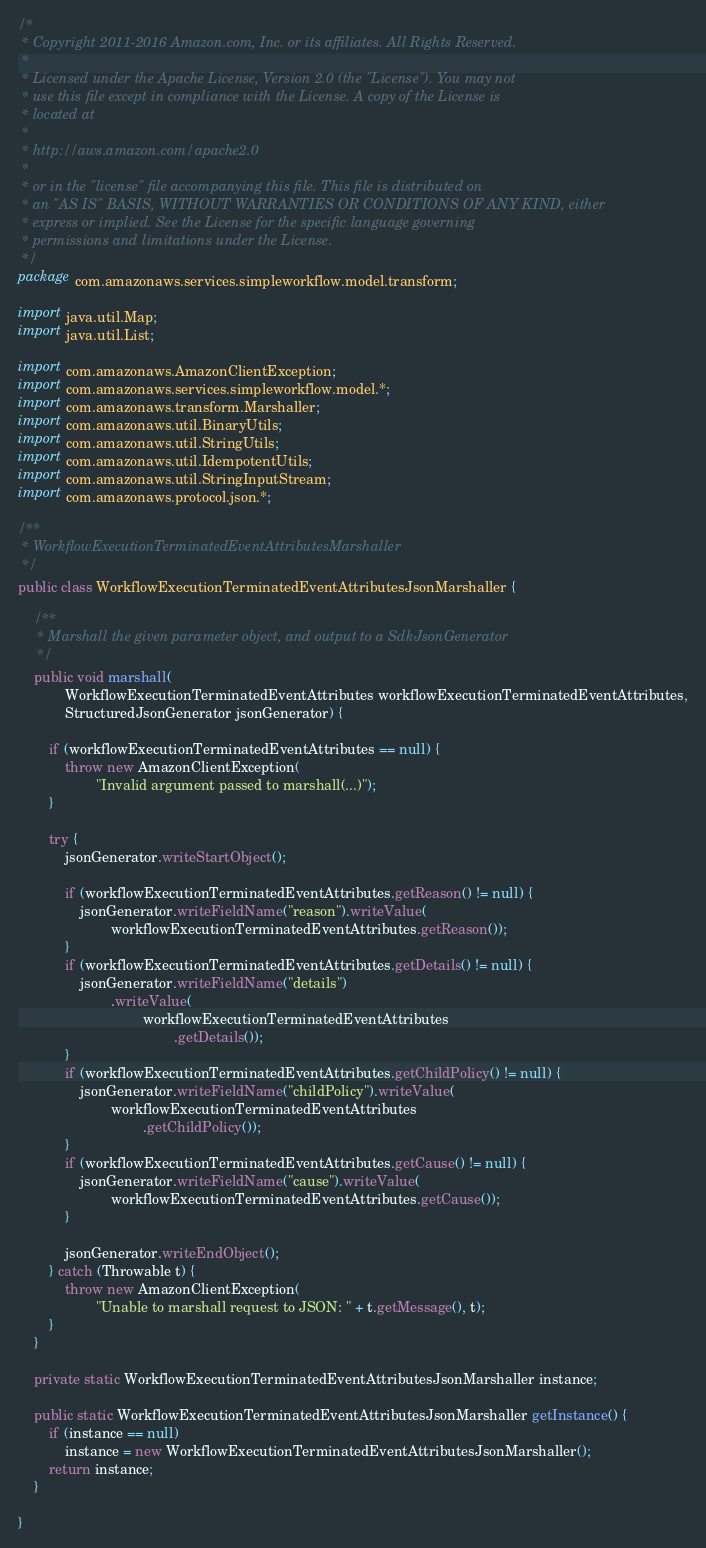<code> <loc_0><loc_0><loc_500><loc_500><_Java_>/*
 * Copyright 2011-2016 Amazon.com, Inc. or its affiliates. All Rights Reserved.
 * 
 * Licensed under the Apache License, Version 2.0 (the "License"). You may not
 * use this file except in compliance with the License. A copy of the License is
 * located at
 * 
 * http://aws.amazon.com/apache2.0
 * 
 * or in the "license" file accompanying this file. This file is distributed on
 * an "AS IS" BASIS, WITHOUT WARRANTIES OR CONDITIONS OF ANY KIND, either
 * express or implied. See the License for the specific language governing
 * permissions and limitations under the License.
 */
package com.amazonaws.services.simpleworkflow.model.transform;

import java.util.Map;
import java.util.List;

import com.amazonaws.AmazonClientException;
import com.amazonaws.services.simpleworkflow.model.*;
import com.amazonaws.transform.Marshaller;
import com.amazonaws.util.BinaryUtils;
import com.amazonaws.util.StringUtils;
import com.amazonaws.util.IdempotentUtils;
import com.amazonaws.util.StringInputStream;
import com.amazonaws.protocol.json.*;

/**
 * WorkflowExecutionTerminatedEventAttributesMarshaller
 */
public class WorkflowExecutionTerminatedEventAttributesJsonMarshaller {

    /**
     * Marshall the given parameter object, and output to a SdkJsonGenerator
     */
    public void marshall(
            WorkflowExecutionTerminatedEventAttributes workflowExecutionTerminatedEventAttributes,
            StructuredJsonGenerator jsonGenerator) {

        if (workflowExecutionTerminatedEventAttributes == null) {
            throw new AmazonClientException(
                    "Invalid argument passed to marshall(...)");
        }

        try {
            jsonGenerator.writeStartObject();

            if (workflowExecutionTerminatedEventAttributes.getReason() != null) {
                jsonGenerator.writeFieldName("reason").writeValue(
                        workflowExecutionTerminatedEventAttributes.getReason());
            }
            if (workflowExecutionTerminatedEventAttributes.getDetails() != null) {
                jsonGenerator.writeFieldName("details")
                        .writeValue(
                                workflowExecutionTerminatedEventAttributes
                                        .getDetails());
            }
            if (workflowExecutionTerminatedEventAttributes.getChildPolicy() != null) {
                jsonGenerator.writeFieldName("childPolicy").writeValue(
                        workflowExecutionTerminatedEventAttributes
                                .getChildPolicy());
            }
            if (workflowExecutionTerminatedEventAttributes.getCause() != null) {
                jsonGenerator.writeFieldName("cause").writeValue(
                        workflowExecutionTerminatedEventAttributes.getCause());
            }

            jsonGenerator.writeEndObject();
        } catch (Throwable t) {
            throw new AmazonClientException(
                    "Unable to marshall request to JSON: " + t.getMessage(), t);
        }
    }

    private static WorkflowExecutionTerminatedEventAttributesJsonMarshaller instance;

    public static WorkflowExecutionTerminatedEventAttributesJsonMarshaller getInstance() {
        if (instance == null)
            instance = new WorkflowExecutionTerminatedEventAttributesJsonMarshaller();
        return instance;
    }

}
</code> 